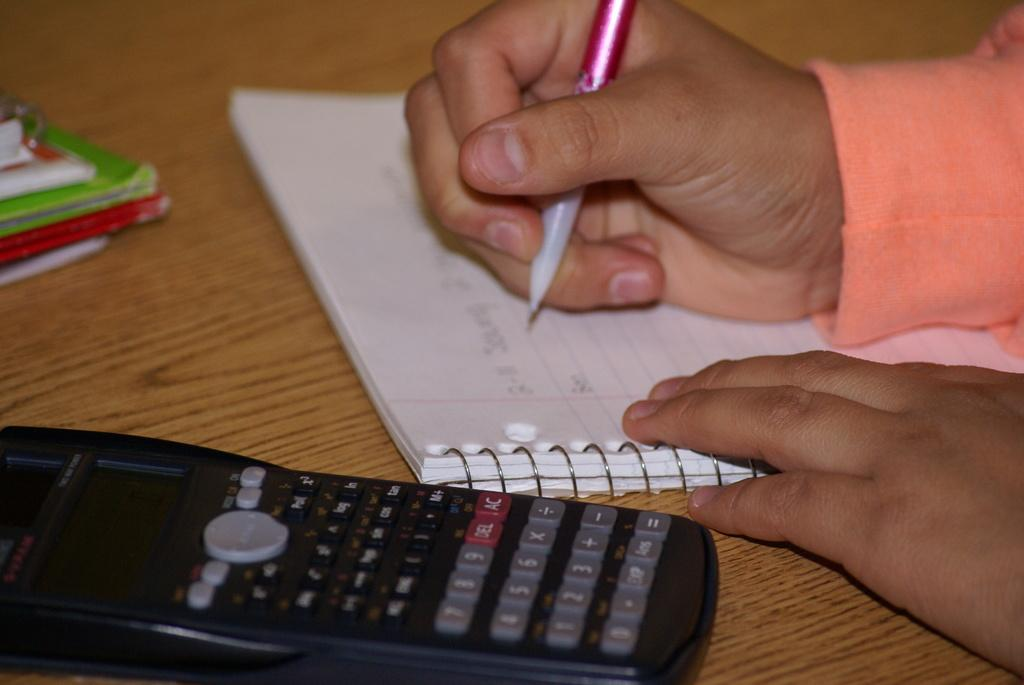<image>
Give a short and clear explanation of the subsequent image. A black calculator has grey and black keys and two red keys that say DEL and AC. 